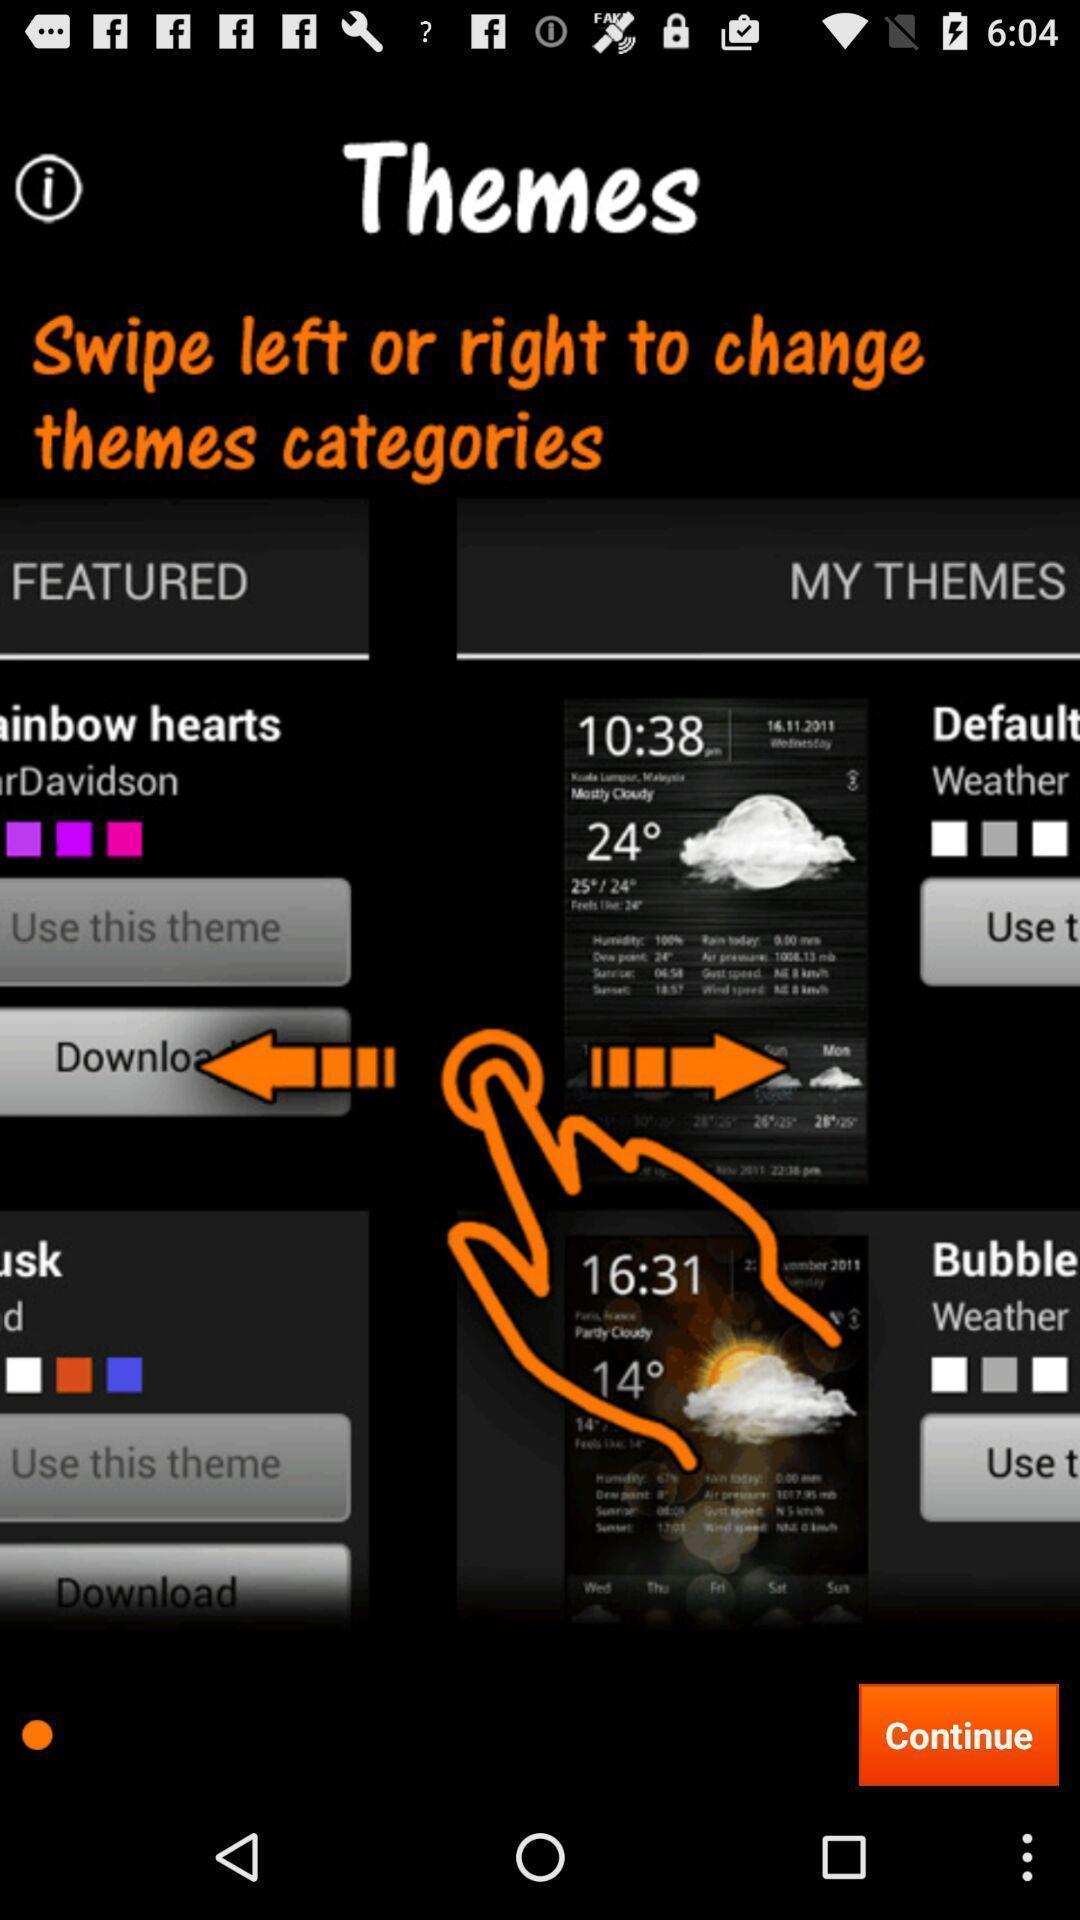Tell me what you see in this picture. Themes page with navigation guide in display. 